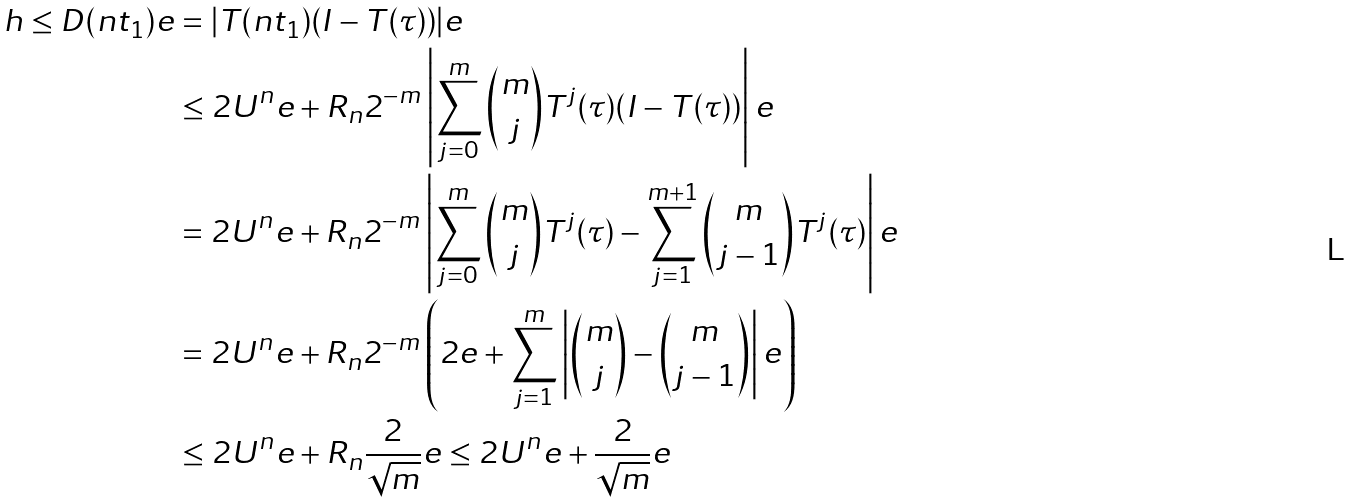Convert formula to latex. <formula><loc_0><loc_0><loc_500><loc_500>h \leq D ( n t _ { 1 } ) e & = | T ( n t _ { 1 } ) ( I - T ( \tau ) ) | e \\ & \leq 2 U ^ { n } e + R _ { n } 2 ^ { - m } \left | \sum _ { j = 0 } ^ { m } \binom { m } { j } T ^ { j } ( \tau ) ( I - T ( \tau ) ) \right | e \\ & = 2 U ^ { n } e + R _ { n } 2 ^ { - m } \left | \sum _ { j = 0 } ^ { m } \binom { m } { j } T ^ { j } ( \tau ) - \sum _ { j = 1 } ^ { m + 1 } \binom { m } { j - 1 } T ^ { j } ( \tau ) \right | e \\ & = 2 U ^ { n } e + R _ { n } 2 ^ { - m } \left ( 2 e + \sum _ { j = 1 } ^ { m } \left | \binom { m } { j } - \binom { m } { j - 1 } \right | e \right ) \\ & \leq 2 U ^ { n } e + R _ { n } \frac { 2 } { \sqrt { m } } e \leq 2 U ^ { n } e + \frac { 2 } { \sqrt { m } } e</formula> 